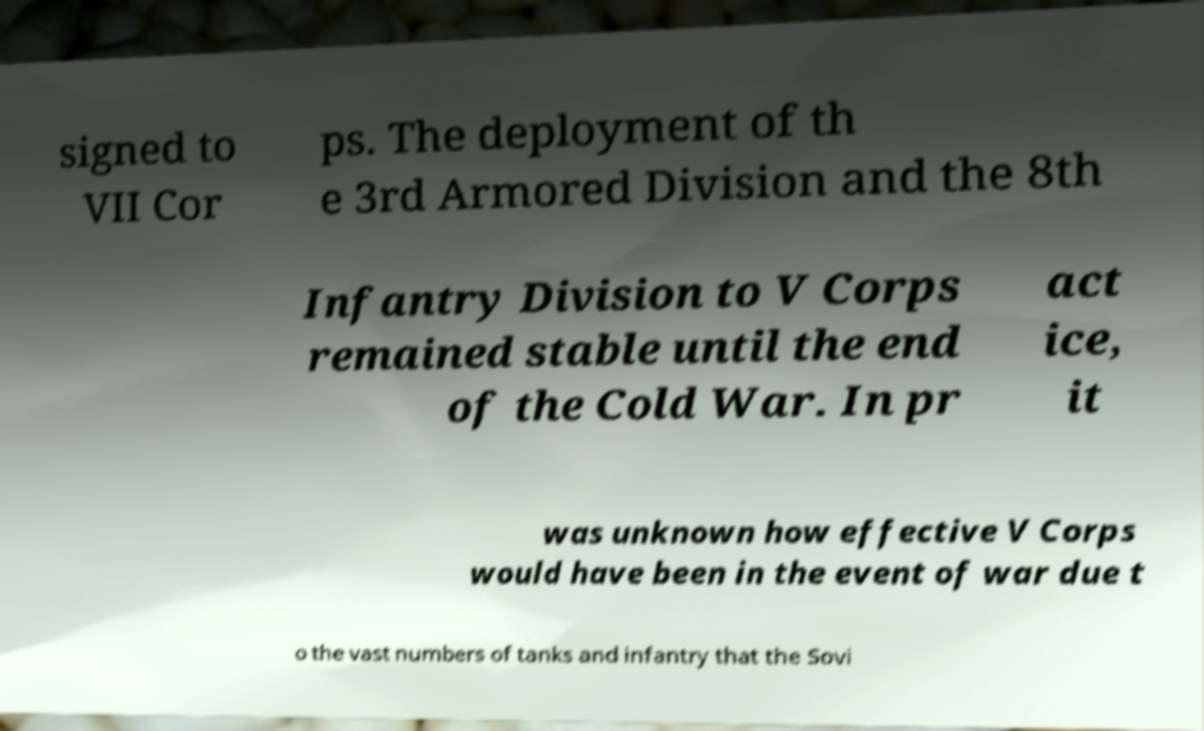There's text embedded in this image that I need extracted. Can you transcribe it verbatim? signed to VII Cor ps. The deployment of th e 3rd Armored Division and the 8th Infantry Division to V Corps remained stable until the end of the Cold War. In pr act ice, it was unknown how effective V Corps would have been in the event of war due t o the vast numbers of tanks and infantry that the Sovi 